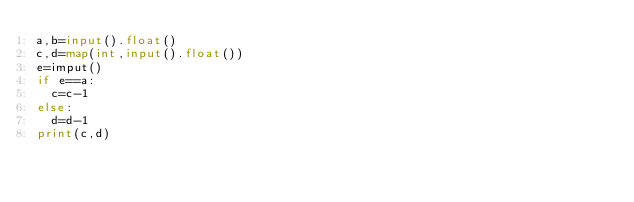Convert code to text. <code><loc_0><loc_0><loc_500><loc_500><_Python_>a,b=input().float()
c,d=map(int,input().float())
e=imput()
if e==a:
  c=c-1
else:
  d=d-1
print(c,d)
</code> 